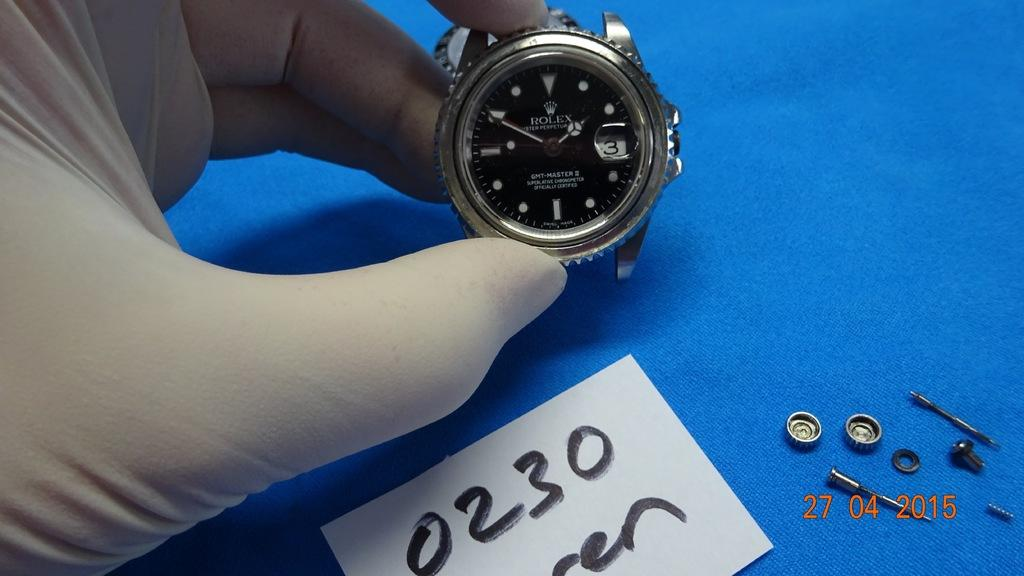<image>
Write a terse but informative summary of the picture. A latex gloved hand is holding up a Rolex watch being fixed. 